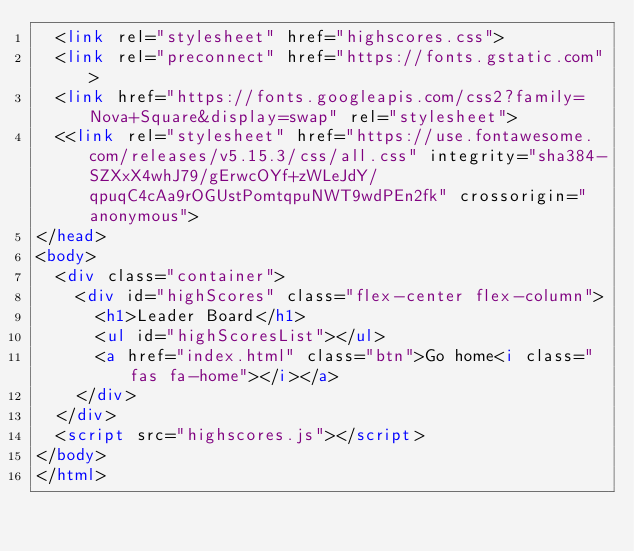Convert code to text. <code><loc_0><loc_0><loc_500><loc_500><_HTML_>  <link rel="stylesheet" href="highscores.css">
  <link rel="preconnect" href="https://fonts.gstatic.com">
  <link href="https://fonts.googleapis.com/css2?family=Nova+Square&display=swap" rel="stylesheet">
  <<link rel="stylesheet" href="https://use.fontawesome.com/releases/v5.15.3/css/all.css" integrity="sha384-SZXxX4whJ79/gErwcOYf+zWLeJdY/qpuqC4cAa9rOGUstPomtqpuNWT9wdPEn2fk" crossorigin="anonymous">
</head>
<body>
  <div class="container">
    <div id="highScores" class="flex-center flex-column">
      <h1>Leader Board</h1>
      <ul id="highScoresList"></ul>
      <a href="index.html" class="btn">Go home<i class="fas fa-home"></i></a>
    </div>
  </div>
  <script src="highscores.js"></script>
</body>
</html></code> 